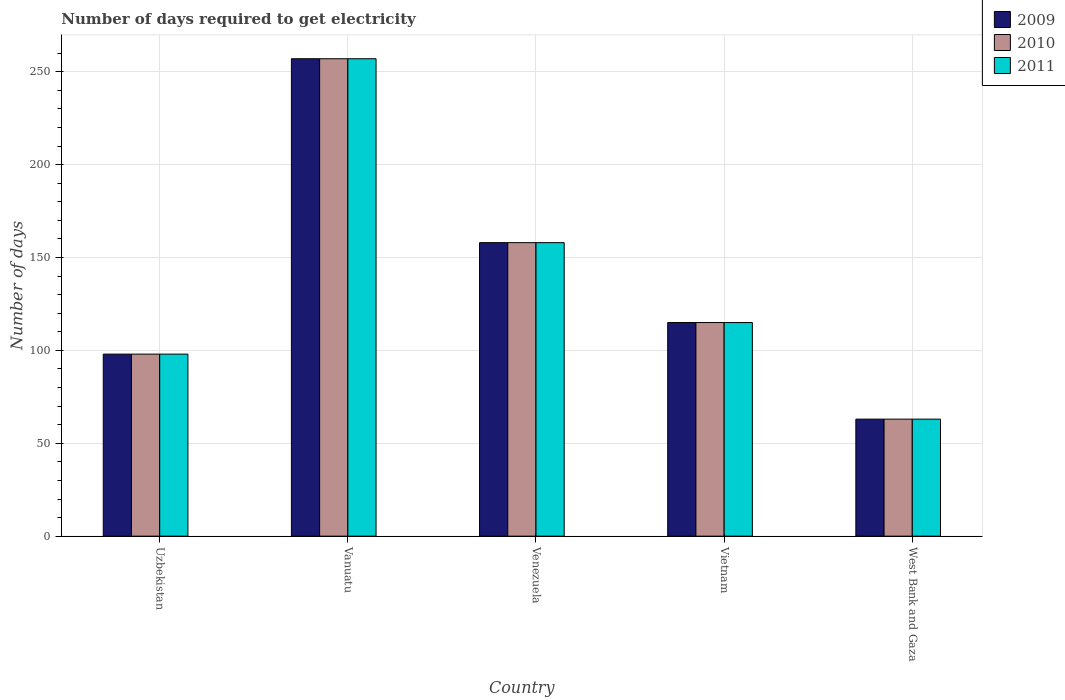How many groups of bars are there?
Offer a very short reply. 5. Are the number of bars per tick equal to the number of legend labels?
Offer a terse response. Yes. How many bars are there on the 3rd tick from the left?
Ensure brevity in your answer.  3. How many bars are there on the 1st tick from the right?
Offer a very short reply. 3. What is the label of the 3rd group of bars from the left?
Ensure brevity in your answer.  Venezuela. Across all countries, what is the maximum number of days required to get electricity in in 2010?
Make the answer very short. 257. In which country was the number of days required to get electricity in in 2010 maximum?
Ensure brevity in your answer.  Vanuatu. In which country was the number of days required to get electricity in in 2011 minimum?
Ensure brevity in your answer.  West Bank and Gaza. What is the total number of days required to get electricity in in 2010 in the graph?
Provide a succinct answer. 691. What is the difference between the number of days required to get electricity in in 2009 in Venezuela and that in Vietnam?
Make the answer very short. 43. What is the difference between the number of days required to get electricity in in 2010 in Uzbekistan and the number of days required to get electricity in in 2011 in Vietnam?
Your answer should be compact. -17. What is the average number of days required to get electricity in in 2009 per country?
Offer a very short reply. 138.2. What is the difference between the number of days required to get electricity in of/in 2010 and number of days required to get electricity in of/in 2009 in West Bank and Gaza?
Ensure brevity in your answer.  0. What is the ratio of the number of days required to get electricity in in 2010 in Vanuatu to that in West Bank and Gaza?
Offer a very short reply. 4.08. Is the difference between the number of days required to get electricity in in 2010 in Venezuela and West Bank and Gaza greater than the difference between the number of days required to get electricity in in 2009 in Venezuela and West Bank and Gaza?
Offer a terse response. No. What is the difference between the highest and the second highest number of days required to get electricity in in 2011?
Give a very brief answer. 142. What is the difference between the highest and the lowest number of days required to get electricity in in 2010?
Provide a succinct answer. 194. In how many countries, is the number of days required to get electricity in in 2010 greater than the average number of days required to get electricity in in 2010 taken over all countries?
Make the answer very short. 2. Are all the bars in the graph horizontal?
Your answer should be very brief. No. How many countries are there in the graph?
Your response must be concise. 5. Where does the legend appear in the graph?
Provide a short and direct response. Top right. How are the legend labels stacked?
Provide a succinct answer. Vertical. What is the title of the graph?
Give a very brief answer. Number of days required to get electricity. What is the label or title of the Y-axis?
Offer a terse response. Number of days. What is the Number of days of 2009 in Vanuatu?
Your answer should be very brief. 257. What is the Number of days in 2010 in Vanuatu?
Keep it short and to the point. 257. What is the Number of days of 2011 in Vanuatu?
Offer a very short reply. 257. What is the Number of days in 2009 in Venezuela?
Keep it short and to the point. 158. What is the Number of days of 2010 in Venezuela?
Provide a short and direct response. 158. What is the Number of days of 2011 in Venezuela?
Your response must be concise. 158. What is the Number of days in 2009 in Vietnam?
Provide a succinct answer. 115. What is the Number of days in 2010 in Vietnam?
Keep it short and to the point. 115. What is the Number of days of 2011 in Vietnam?
Provide a succinct answer. 115. What is the Number of days in 2009 in West Bank and Gaza?
Keep it short and to the point. 63. What is the Number of days of 2011 in West Bank and Gaza?
Your answer should be compact. 63. Across all countries, what is the maximum Number of days of 2009?
Make the answer very short. 257. Across all countries, what is the maximum Number of days of 2010?
Offer a terse response. 257. Across all countries, what is the maximum Number of days of 2011?
Provide a short and direct response. 257. Across all countries, what is the minimum Number of days of 2011?
Provide a succinct answer. 63. What is the total Number of days in 2009 in the graph?
Give a very brief answer. 691. What is the total Number of days of 2010 in the graph?
Your response must be concise. 691. What is the total Number of days of 2011 in the graph?
Your answer should be very brief. 691. What is the difference between the Number of days in 2009 in Uzbekistan and that in Vanuatu?
Give a very brief answer. -159. What is the difference between the Number of days in 2010 in Uzbekistan and that in Vanuatu?
Offer a very short reply. -159. What is the difference between the Number of days of 2011 in Uzbekistan and that in Vanuatu?
Your response must be concise. -159. What is the difference between the Number of days of 2009 in Uzbekistan and that in Venezuela?
Offer a very short reply. -60. What is the difference between the Number of days of 2010 in Uzbekistan and that in Venezuela?
Give a very brief answer. -60. What is the difference between the Number of days of 2011 in Uzbekistan and that in Venezuela?
Provide a succinct answer. -60. What is the difference between the Number of days in 2009 in Uzbekistan and that in Vietnam?
Your response must be concise. -17. What is the difference between the Number of days in 2010 in Uzbekistan and that in Vietnam?
Offer a terse response. -17. What is the difference between the Number of days in 2009 in Uzbekistan and that in West Bank and Gaza?
Your answer should be very brief. 35. What is the difference between the Number of days in 2010 in Uzbekistan and that in West Bank and Gaza?
Keep it short and to the point. 35. What is the difference between the Number of days in 2010 in Vanuatu and that in Venezuela?
Your response must be concise. 99. What is the difference between the Number of days of 2011 in Vanuatu and that in Venezuela?
Give a very brief answer. 99. What is the difference between the Number of days of 2009 in Vanuatu and that in Vietnam?
Your response must be concise. 142. What is the difference between the Number of days of 2010 in Vanuatu and that in Vietnam?
Offer a terse response. 142. What is the difference between the Number of days in 2011 in Vanuatu and that in Vietnam?
Keep it short and to the point. 142. What is the difference between the Number of days of 2009 in Vanuatu and that in West Bank and Gaza?
Make the answer very short. 194. What is the difference between the Number of days in 2010 in Vanuatu and that in West Bank and Gaza?
Give a very brief answer. 194. What is the difference between the Number of days in 2011 in Vanuatu and that in West Bank and Gaza?
Provide a short and direct response. 194. What is the difference between the Number of days in 2010 in Venezuela and that in Vietnam?
Offer a very short reply. 43. What is the difference between the Number of days in 2011 in Venezuela and that in Vietnam?
Keep it short and to the point. 43. What is the difference between the Number of days in 2009 in Venezuela and that in West Bank and Gaza?
Your response must be concise. 95. What is the difference between the Number of days of 2010 in Venezuela and that in West Bank and Gaza?
Your answer should be very brief. 95. What is the difference between the Number of days in 2011 in Venezuela and that in West Bank and Gaza?
Your answer should be compact. 95. What is the difference between the Number of days in 2009 in Vietnam and that in West Bank and Gaza?
Your answer should be very brief. 52. What is the difference between the Number of days in 2010 in Vietnam and that in West Bank and Gaza?
Provide a succinct answer. 52. What is the difference between the Number of days of 2011 in Vietnam and that in West Bank and Gaza?
Your answer should be very brief. 52. What is the difference between the Number of days of 2009 in Uzbekistan and the Number of days of 2010 in Vanuatu?
Give a very brief answer. -159. What is the difference between the Number of days of 2009 in Uzbekistan and the Number of days of 2011 in Vanuatu?
Your response must be concise. -159. What is the difference between the Number of days in 2010 in Uzbekistan and the Number of days in 2011 in Vanuatu?
Provide a succinct answer. -159. What is the difference between the Number of days of 2009 in Uzbekistan and the Number of days of 2010 in Venezuela?
Provide a succinct answer. -60. What is the difference between the Number of days of 2009 in Uzbekistan and the Number of days of 2011 in Venezuela?
Offer a very short reply. -60. What is the difference between the Number of days in 2010 in Uzbekistan and the Number of days in 2011 in Venezuela?
Your answer should be very brief. -60. What is the difference between the Number of days in 2009 in Uzbekistan and the Number of days in 2010 in Vietnam?
Make the answer very short. -17. What is the difference between the Number of days of 2009 in Uzbekistan and the Number of days of 2011 in Vietnam?
Your answer should be very brief. -17. What is the difference between the Number of days in 2009 in Uzbekistan and the Number of days in 2010 in West Bank and Gaza?
Provide a succinct answer. 35. What is the difference between the Number of days in 2010 in Uzbekistan and the Number of days in 2011 in West Bank and Gaza?
Your answer should be very brief. 35. What is the difference between the Number of days of 2009 in Vanuatu and the Number of days of 2010 in Venezuela?
Your answer should be very brief. 99. What is the difference between the Number of days in 2009 in Vanuatu and the Number of days in 2011 in Venezuela?
Provide a short and direct response. 99. What is the difference between the Number of days in 2009 in Vanuatu and the Number of days in 2010 in Vietnam?
Your answer should be very brief. 142. What is the difference between the Number of days in 2009 in Vanuatu and the Number of days in 2011 in Vietnam?
Give a very brief answer. 142. What is the difference between the Number of days of 2010 in Vanuatu and the Number of days of 2011 in Vietnam?
Provide a short and direct response. 142. What is the difference between the Number of days of 2009 in Vanuatu and the Number of days of 2010 in West Bank and Gaza?
Keep it short and to the point. 194. What is the difference between the Number of days in 2009 in Vanuatu and the Number of days in 2011 in West Bank and Gaza?
Your response must be concise. 194. What is the difference between the Number of days in 2010 in Vanuatu and the Number of days in 2011 in West Bank and Gaza?
Offer a terse response. 194. What is the difference between the Number of days of 2009 in Venezuela and the Number of days of 2011 in Vietnam?
Your response must be concise. 43. What is the difference between the Number of days of 2009 in Venezuela and the Number of days of 2010 in West Bank and Gaza?
Your answer should be very brief. 95. What is the difference between the Number of days in 2009 in Venezuela and the Number of days in 2011 in West Bank and Gaza?
Offer a very short reply. 95. What is the difference between the Number of days in 2010 in Venezuela and the Number of days in 2011 in West Bank and Gaza?
Your response must be concise. 95. What is the difference between the Number of days of 2009 in Vietnam and the Number of days of 2010 in West Bank and Gaza?
Offer a very short reply. 52. What is the difference between the Number of days in 2009 in Vietnam and the Number of days in 2011 in West Bank and Gaza?
Your answer should be compact. 52. What is the difference between the Number of days of 2010 in Vietnam and the Number of days of 2011 in West Bank and Gaza?
Provide a short and direct response. 52. What is the average Number of days of 2009 per country?
Your answer should be very brief. 138.2. What is the average Number of days in 2010 per country?
Offer a terse response. 138.2. What is the average Number of days of 2011 per country?
Your answer should be very brief. 138.2. What is the difference between the Number of days of 2009 and Number of days of 2010 in Uzbekistan?
Your answer should be very brief. 0. What is the difference between the Number of days in 2010 and Number of days in 2011 in Uzbekistan?
Your response must be concise. 0. What is the difference between the Number of days of 2009 and Number of days of 2010 in Vanuatu?
Provide a succinct answer. 0. What is the difference between the Number of days in 2009 and Number of days in 2010 in Venezuela?
Your answer should be very brief. 0. What is the difference between the Number of days of 2010 and Number of days of 2011 in Venezuela?
Provide a succinct answer. 0. What is the difference between the Number of days in 2009 and Number of days in 2010 in Vietnam?
Make the answer very short. 0. What is the difference between the Number of days of 2009 and Number of days of 2011 in Vietnam?
Your answer should be very brief. 0. What is the difference between the Number of days in 2009 and Number of days in 2011 in West Bank and Gaza?
Give a very brief answer. 0. What is the difference between the Number of days in 2010 and Number of days in 2011 in West Bank and Gaza?
Your answer should be compact. 0. What is the ratio of the Number of days of 2009 in Uzbekistan to that in Vanuatu?
Provide a short and direct response. 0.38. What is the ratio of the Number of days in 2010 in Uzbekistan to that in Vanuatu?
Your answer should be very brief. 0.38. What is the ratio of the Number of days of 2011 in Uzbekistan to that in Vanuatu?
Your response must be concise. 0.38. What is the ratio of the Number of days in 2009 in Uzbekistan to that in Venezuela?
Your answer should be compact. 0.62. What is the ratio of the Number of days in 2010 in Uzbekistan to that in Venezuela?
Your response must be concise. 0.62. What is the ratio of the Number of days of 2011 in Uzbekistan to that in Venezuela?
Provide a succinct answer. 0.62. What is the ratio of the Number of days in 2009 in Uzbekistan to that in Vietnam?
Provide a short and direct response. 0.85. What is the ratio of the Number of days in 2010 in Uzbekistan to that in Vietnam?
Give a very brief answer. 0.85. What is the ratio of the Number of days of 2011 in Uzbekistan to that in Vietnam?
Your response must be concise. 0.85. What is the ratio of the Number of days in 2009 in Uzbekistan to that in West Bank and Gaza?
Your answer should be compact. 1.56. What is the ratio of the Number of days of 2010 in Uzbekistan to that in West Bank and Gaza?
Offer a very short reply. 1.56. What is the ratio of the Number of days of 2011 in Uzbekistan to that in West Bank and Gaza?
Offer a terse response. 1.56. What is the ratio of the Number of days of 2009 in Vanuatu to that in Venezuela?
Give a very brief answer. 1.63. What is the ratio of the Number of days of 2010 in Vanuatu to that in Venezuela?
Give a very brief answer. 1.63. What is the ratio of the Number of days in 2011 in Vanuatu to that in Venezuela?
Ensure brevity in your answer.  1.63. What is the ratio of the Number of days in 2009 in Vanuatu to that in Vietnam?
Make the answer very short. 2.23. What is the ratio of the Number of days of 2010 in Vanuatu to that in Vietnam?
Offer a terse response. 2.23. What is the ratio of the Number of days of 2011 in Vanuatu to that in Vietnam?
Keep it short and to the point. 2.23. What is the ratio of the Number of days in 2009 in Vanuatu to that in West Bank and Gaza?
Your answer should be very brief. 4.08. What is the ratio of the Number of days in 2010 in Vanuatu to that in West Bank and Gaza?
Your answer should be very brief. 4.08. What is the ratio of the Number of days of 2011 in Vanuatu to that in West Bank and Gaza?
Your answer should be very brief. 4.08. What is the ratio of the Number of days in 2009 in Venezuela to that in Vietnam?
Your response must be concise. 1.37. What is the ratio of the Number of days of 2010 in Venezuela to that in Vietnam?
Your answer should be compact. 1.37. What is the ratio of the Number of days of 2011 in Venezuela to that in Vietnam?
Make the answer very short. 1.37. What is the ratio of the Number of days in 2009 in Venezuela to that in West Bank and Gaza?
Your response must be concise. 2.51. What is the ratio of the Number of days in 2010 in Venezuela to that in West Bank and Gaza?
Offer a terse response. 2.51. What is the ratio of the Number of days of 2011 in Venezuela to that in West Bank and Gaza?
Provide a short and direct response. 2.51. What is the ratio of the Number of days of 2009 in Vietnam to that in West Bank and Gaza?
Provide a short and direct response. 1.83. What is the ratio of the Number of days in 2010 in Vietnam to that in West Bank and Gaza?
Provide a short and direct response. 1.83. What is the ratio of the Number of days of 2011 in Vietnam to that in West Bank and Gaza?
Your answer should be very brief. 1.83. What is the difference between the highest and the second highest Number of days of 2009?
Offer a terse response. 99. What is the difference between the highest and the second highest Number of days of 2010?
Keep it short and to the point. 99. What is the difference between the highest and the lowest Number of days of 2009?
Your response must be concise. 194. What is the difference between the highest and the lowest Number of days in 2010?
Make the answer very short. 194. What is the difference between the highest and the lowest Number of days of 2011?
Give a very brief answer. 194. 